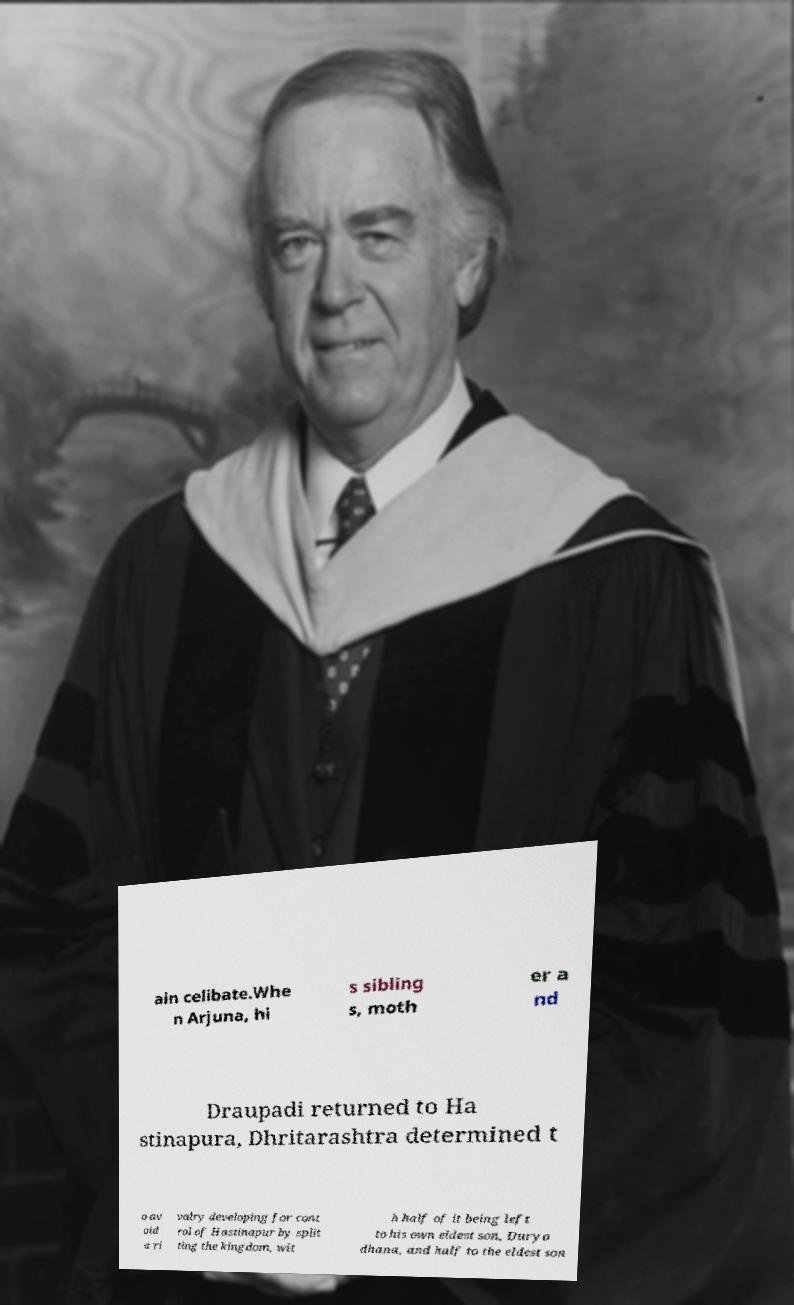Can you read and provide the text displayed in the image?This photo seems to have some interesting text. Can you extract and type it out for me? ain celibate.Whe n Arjuna, hi s sibling s, moth er a nd Draupadi returned to Ha stinapura, Dhritarashtra determined t o av oid a ri valry developing for cont rol of Hastinapur by split ting the kingdom, wit h half of it being left to his own eldest son, Duryo dhana, and half to the eldest son 